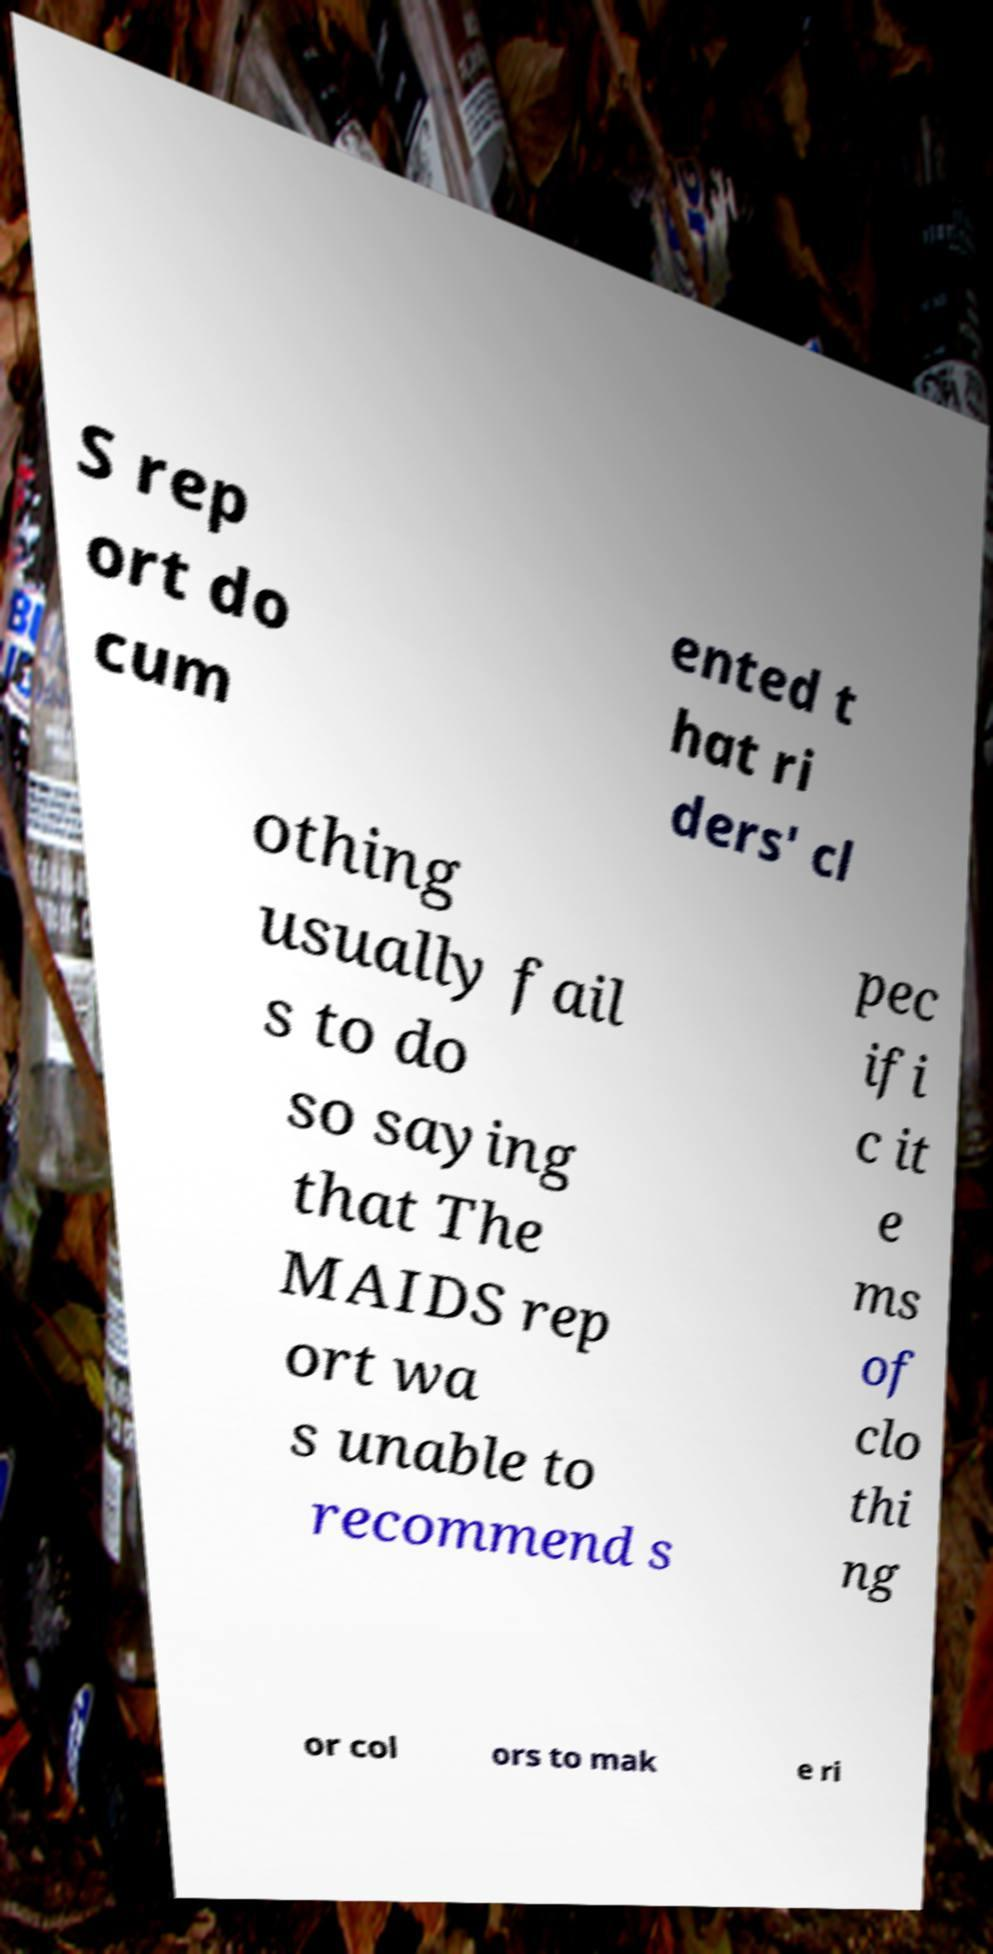For documentation purposes, I need the text within this image transcribed. Could you provide that? S rep ort do cum ented t hat ri ders' cl othing usually fail s to do so saying that The MAIDS rep ort wa s unable to recommend s pec ifi c it e ms of clo thi ng or col ors to mak e ri 